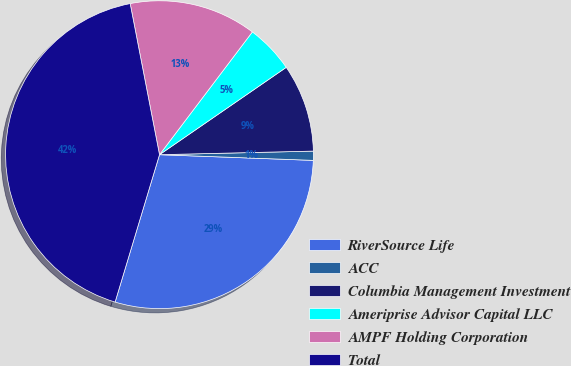<chart> <loc_0><loc_0><loc_500><loc_500><pie_chart><fcel>RiverSource Life<fcel>ACC<fcel>Columbia Management Investment<fcel>Ameriprise Advisor Capital LLC<fcel>AMPF Holding Corporation<fcel>Total<nl><fcel>29.07%<fcel>0.96%<fcel>9.23%<fcel>5.09%<fcel>13.36%<fcel>42.29%<nl></chart> 